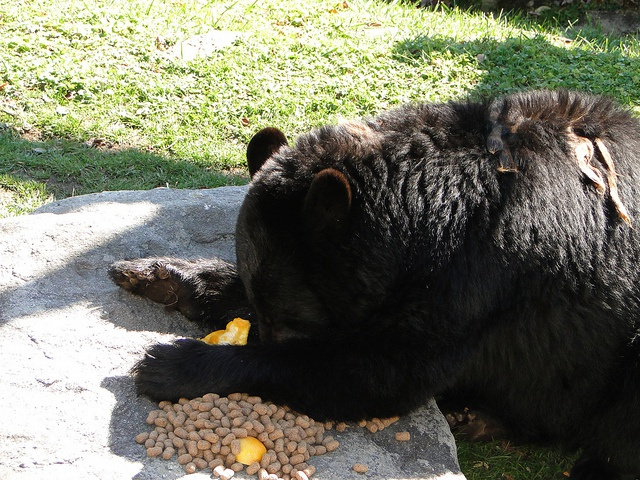Describe the objects in this image and their specific colors. I can see bear in beige, black, gray, darkgray, and lightgray tones, orange in beige, orange, tan, and black tones, and orange in beige, gold, orange, and brown tones in this image. 